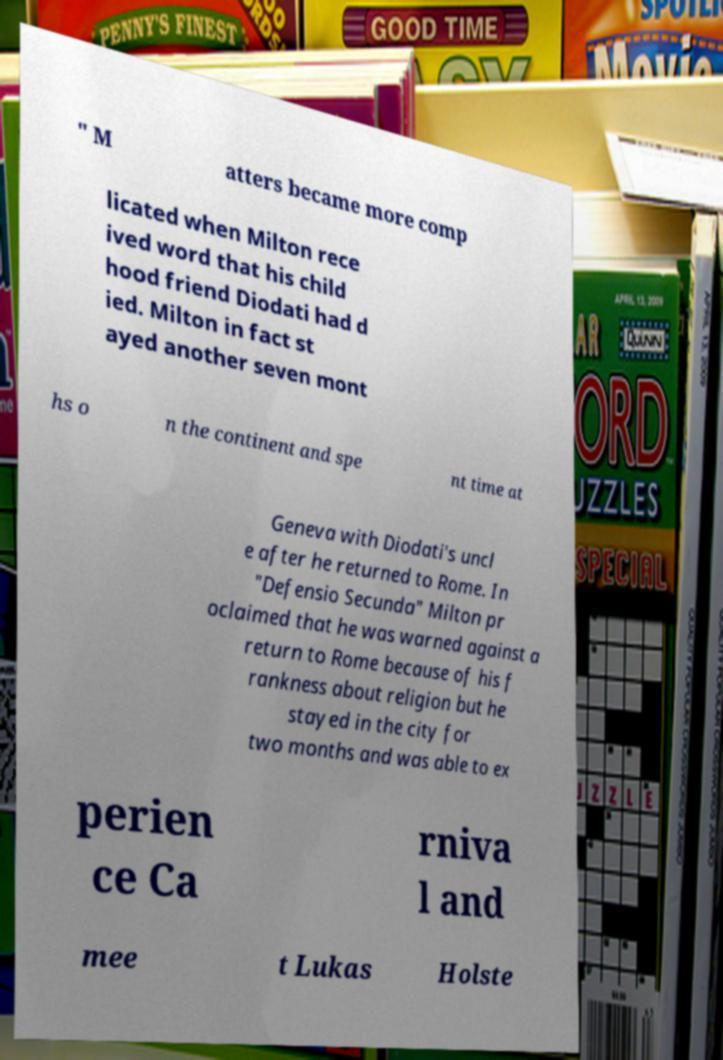There's text embedded in this image that I need extracted. Can you transcribe it verbatim? " M atters became more comp licated when Milton rece ived word that his child hood friend Diodati had d ied. Milton in fact st ayed another seven mont hs o n the continent and spe nt time at Geneva with Diodati's uncl e after he returned to Rome. In "Defensio Secunda" Milton pr oclaimed that he was warned against a return to Rome because of his f rankness about religion but he stayed in the city for two months and was able to ex perien ce Ca rniva l and mee t Lukas Holste 